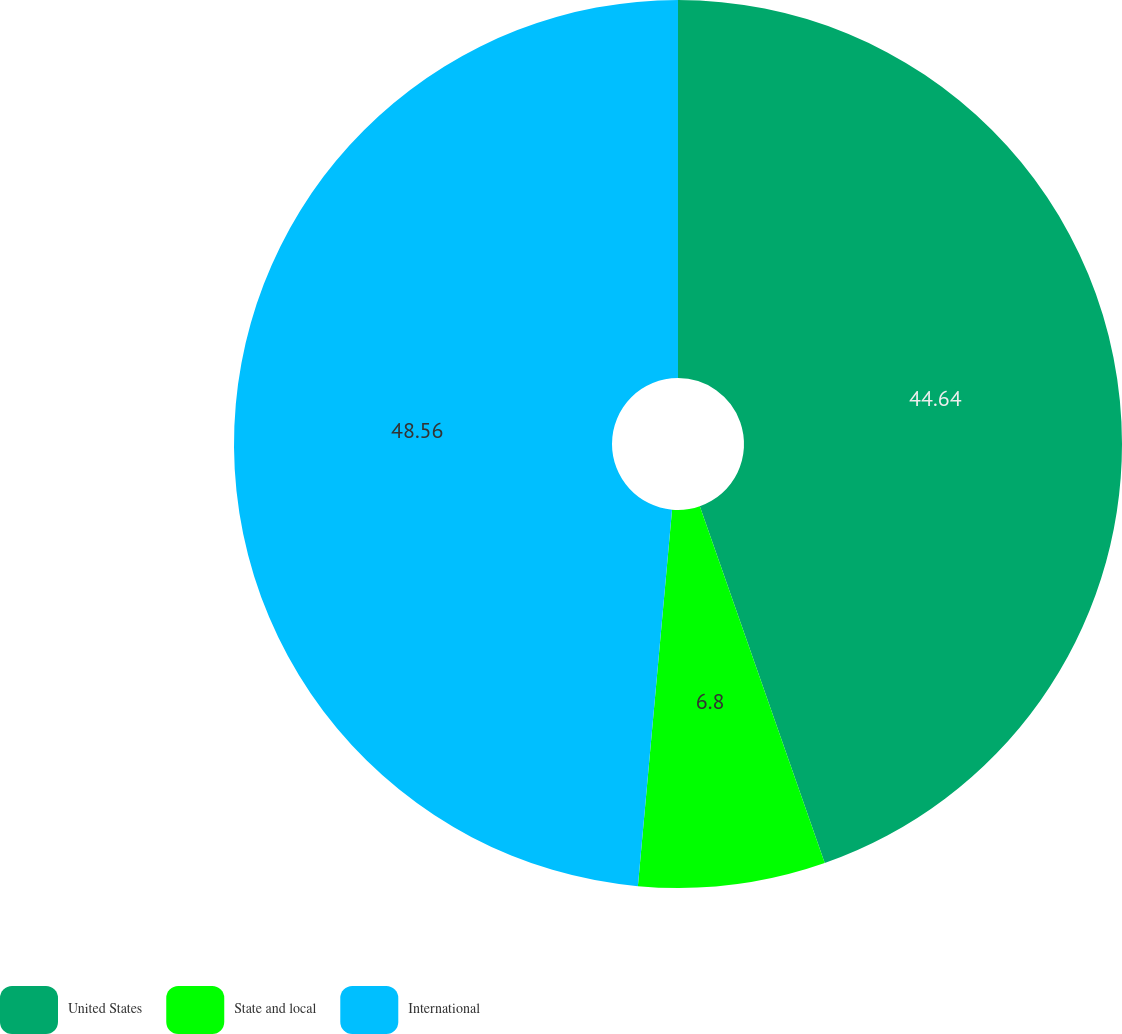Convert chart. <chart><loc_0><loc_0><loc_500><loc_500><pie_chart><fcel>United States<fcel>State and local<fcel>International<nl><fcel>44.64%<fcel>6.8%<fcel>48.56%<nl></chart> 